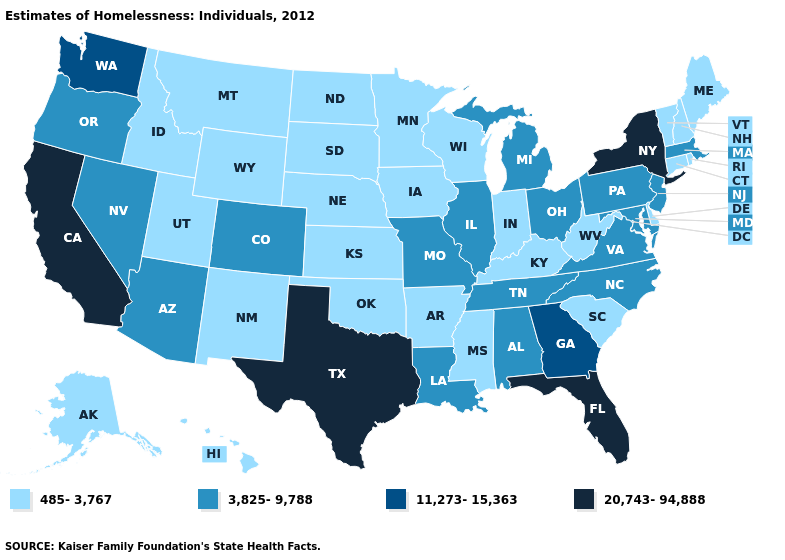Among the states that border Kentucky , which have the lowest value?
Give a very brief answer. Indiana, West Virginia. Which states have the lowest value in the USA?
Be succinct. Alaska, Arkansas, Connecticut, Delaware, Hawaii, Idaho, Indiana, Iowa, Kansas, Kentucky, Maine, Minnesota, Mississippi, Montana, Nebraska, New Hampshire, New Mexico, North Dakota, Oklahoma, Rhode Island, South Carolina, South Dakota, Utah, Vermont, West Virginia, Wisconsin, Wyoming. What is the value of Vermont?
Give a very brief answer. 485-3,767. What is the value of Wisconsin?
Concise answer only. 485-3,767. What is the value of Montana?
Short answer required. 485-3,767. What is the value of Delaware?
Keep it brief. 485-3,767. What is the value of Missouri?
Quick response, please. 3,825-9,788. What is the value of Virginia?
Short answer required. 3,825-9,788. Which states have the lowest value in the USA?
Quick response, please. Alaska, Arkansas, Connecticut, Delaware, Hawaii, Idaho, Indiana, Iowa, Kansas, Kentucky, Maine, Minnesota, Mississippi, Montana, Nebraska, New Hampshire, New Mexico, North Dakota, Oklahoma, Rhode Island, South Carolina, South Dakota, Utah, Vermont, West Virginia, Wisconsin, Wyoming. Name the states that have a value in the range 485-3,767?
Be succinct. Alaska, Arkansas, Connecticut, Delaware, Hawaii, Idaho, Indiana, Iowa, Kansas, Kentucky, Maine, Minnesota, Mississippi, Montana, Nebraska, New Hampshire, New Mexico, North Dakota, Oklahoma, Rhode Island, South Carolina, South Dakota, Utah, Vermont, West Virginia, Wisconsin, Wyoming. Among the states that border Tennessee , which have the lowest value?
Short answer required. Arkansas, Kentucky, Mississippi. Name the states that have a value in the range 20,743-94,888?
Write a very short answer. California, Florida, New York, Texas. What is the highest value in states that border South Carolina?
Answer briefly. 11,273-15,363. Name the states that have a value in the range 485-3,767?
Be succinct. Alaska, Arkansas, Connecticut, Delaware, Hawaii, Idaho, Indiana, Iowa, Kansas, Kentucky, Maine, Minnesota, Mississippi, Montana, Nebraska, New Hampshire, New Mexico, North Dakota, Oklahoma, Rhode Island, South Carolina, South Dakota, Utah, Vermont, West Virginia, Wisconsin, Wyoming. 